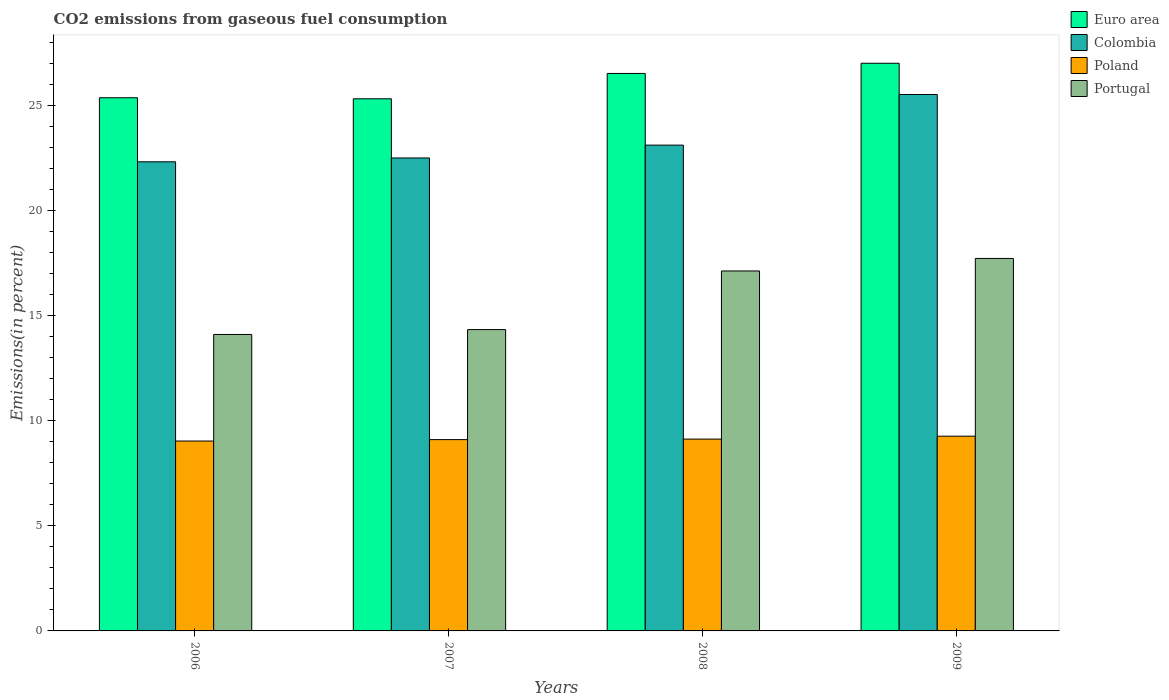How many different coloured bars are there?
Make the answer very short. 4. Are the number of bars on each tick of the X-axis equal?
Give a very brief answer. Yes. What is the label of the 3rd group of bars from the left?
Make the answer very short. 2008. In how many cases, is the number of bars for a given year not equal to the number of legend labels?
Ensure brevity in your answer.  0. What is the total CO2 emitted in Euro area in 2008?
Provide a succinct answer. 26.52. Across all years, what is the maximum total CO2 emitted in Poland?
Your response must be concise. 9.26. Across all years, what is the minimum total CO2 emitted in Poland?
Offer a terse response. 9.03. In which year was the total CO2 emitted in Euro area maximum?
Provide a short and direct response. 2009. What is the total total CO2 emitted in Portugal in the graph?
Provide a short and direct response. 63.27. What is the difference between the total CO2 emitted in Colombia in 2007 and that in 2009?
Give a very brief answer. -3.02. What is the difference between the total CO2 emitted in Portugal in 2007 and the total CO2 emitted in Poland in 2006?
Your answer should be compact. 5.3. What is the average total CO2 emitted in Euro area per year?
Your answer should be very brief. 26.05. In the year 2008, what is the difference between the total CO2 emitted in Colombia and total CO2 emitted in Portugal?
Offer a terse response. 5.99. What is the ratio of the total CO2 emitted in Colombia in 2007 to that in 2008?
Offer a terse response. 0.97. Is the difference between the total CO2 emitted in Colombia in 2007 and 2008 greater than the difference between the total CO2 emitted in Portugal in 2007 and 2008?
Offer a terse response. Yes. What is the difference between the highest and the second highest total CO2 emitted in Poland?
Give a very brief answer. 0.14. What is the difference between the highest and the lowest total CO2 emitted in Portugal?
Your response must be concise. 3.62. In how many years, is the total CO2 emitted in Portugal greater than the average total CO2 emitted in Portugal taken over all years?
Your response must be concise. 2. Is it the case that in every year, the sum of the total CO2 emitted in Portugal and total CO2 emitted in Euro area is greater than the sum of total CO2 emitted in Colombia and total CO2 emitted in Poland?
Ensure brevity in your answer.  Yes. Is it the case that in every year, the sum of the total CO2 emitted in Colombia and total CO2 emitted in Euro area is greater than the total CO2 emitted in Portugal?
Your response must be concise. Yes. How many bars are there?
Provide a succinct answer. 16. How many years are there in the graph?
Give a very brief answer. 4. What is the difference between two consecutive major ticks on the Y-axis?
Make the answer very short. 5. Are the values on the major ticks of Y-axis written in scientific E-notation?
Provide a succinct answer. No. Does the graph contain grids?
Your answer should be compact. No. How many legend labels are there?
Your answer should be very brief. 4. How are the legend labels stacked?
Offer a very short reply. Vertical. What is the title of the graph?
Your answer should be compact. CO2 emissions from gaseous fuel consumption. What is the label or title of the X-axis?
Give a very brief answer. Years. What is the label or title of the Y-axis?
Your response must be concise. Emissions(in percent). What is the Emissions(in percent) in Euro area in 2006?
Give a very brief answer. 25.36. What is the Emissions(in percent) of Colombia in 2006?
Make the answer very short. 22.31. What is the Emissions(in percent) of Poland in 2006?
Ensure brevity in your answer.  9.03. What is the Emissions(in percent) in Portugal in 2006?
Ensure brevity in your answer.  14.1. What is the Emissions(in percent) in Euro area in 2007?
Keep it short and to the point. 25.31. What is the Emissions(in percent) in Colombia in 2007?
Make the answer very short. 22.5. What is the Emissions(in percent) in Poland in 2007?
Offer a very short reply. 9.1. What is the Emissions(in percent) of Portugal in 2007?
Offer a terse response. 14.33. What is the Emissions(in percent) in Euro area in 2008?
Provide a short and direct response. 26.52. What is the Emissions(in percent) of Colombia in 2008?
Your answer should be very brief. 23.11. What is the Emissions(in percent) in Poland in 2008?
Provide a succinct answer. 9.12. What is the Emissions(in percent) of Portugal in 2008?
Offer a terse response. 17.12. What is the Emissions(in percent) of Euro area in 2009?
Provide a short and direct response. 27. What is the Emissions(in percent) in Colombia in 2009?
Provide a succinct answer. 25.52. What is the Emissions(in percent) of Poland in 2009?
Make the answer very short. 9.26. What is the Emissions(in percent) in Portugal in 2009?
Your response must be concise. 17.72. Across all years, what is the maximum Emissions(in percent) of Euro area?
Offer a very short reply. 27. Across all years, what is the maximum Emissions(in percent) of Colombia?
Offer a very short reply. 25.52. Across all years, what is the maximum Emissions(in percent) in Poland?
Your answer should be very brief. 9.26. Across all years, what is the maximum Emissions(in percent) in Portugal?
Provide a succinct answer. 17.72. Across all years, what is the minimum Emissions(in percent) of Euro area?
Keep it short and to the point. 25.31. Across all years, what is the minimum Emissions(in percent) in Colombia?
Offer a very short reply. 22.31. Across all years, what is the minimum Emissions(in percent) in Poland?
Provide a short and direct response. 9.03. Across all years, what is the minimum Emissions(in percent) in Portugal?
Keep it short and to the point. 14.1. What is the total Emissions(in percent) of Euro area in the graph?
Ensure brevity in your answer.  104.19. What is the total Emissions(in percent) of Colombia in the graph?
Give a very brief answer. 93.43. What is the total Emissions(in percent) in Poland in the graph?
Make the answer very short. 36.52. What is the total Emissions(in percent) in Portugal in the graph?
Your response must be concise. 63.27. What is the difference between the Emissions(in percent) of Euro area in 2006 and that in 2007?
Offer a terse response. 0.05. What is the difference between the Emissions(in percent) in Colombia in 2006 and that in 2007?
Give a very brief answer. -0.18. What is the difference between the Emissions(in percent) in Poland in 2006 and that in 2007?
Give a very brief answer. -0.07. What is the difference between the Emissions(in percent) in Portugal in 2006 and that in 2007?
Keep it short and to the point. -0.23. What is the difference between the Emissions(in percent) of Euro area in 2006 and that in 2008?
Keep it short and to the point. -1.16. What is the difference between the Emissions(in percent) of Colombia in 2006 and that in 2008?
Give a very brief answer. -0.79. What is the difference between the Emissions(in percent) of Poland in 2006 and that in 2008?
Make the answer very short. -0.09. What is the difference between the Emissions(in percent) in Portugal in 2006 and that in 2008?
Keep it short and to the point. -3.02. What is the difference between the Emissions(in percent) in Euro area in 2006 and that in 2009?
Offer a terse response. -1.64. What is the difference between the Emissions(in percent) in Colombia in 2006 and that in 2009?
Provide a succinct answer. -3.2. What is the difference between the Emissions(in percent) of Poland in 2006 and that in 2009?
Your response must be concise. -0.23. What is the difference between the Emissions(in percent) of Portugal in 2006 and that in 2009?
Your response must be concise. -3.62. What is the difference between the Emissions(in percent) of Euro area in 2007 and that in 2008?
Keep it short and to the point. -1.21. What is the difference between the Emissions(in percent) of Colombia in 2007 and that in 2008?
Offer a terse response. -0.61. What is the difference between the Emissions(in percent) of Poland in 2007 and that in 2008?
Offer a very short reply. -0.02. What is the difference between the Emissions(in percent) of Portugal in 2007 and that in 2008?
Make the answer very short. -2.79. What is the difference between the Emissions(in percent) of Euro area in 2007 and that in 2009?
Offer a terse response. -1.69. What is the difference between the Emissions(in percent) of Colombia in 2007 and that in 2009?
Keep it short and to the point. -3.02. What is the difference between the Emissions(in percent) in Poland in 2007 and that in 2009?
Your response must be concise. -0.16. What is the difference between the Emissions(in percent) of Portugal in 2007 and that in 2009?
Offer a terse response. -3.38. What is the difference between the Emissions(in percent) in Euro area in 2008 and that in 2009?
Offer a terse response. -0.48. What is the difference between the Emissions(in percent) in Colombia in 2008 and that in 2009?
Your answer should be compact. -2.41. What is the difference between the Emissions(in percent) in Poland in 2008 and that in 2009?
Offer a very short reply. -0.14. What is the difference between the Emissions(in percent) of Portugal in 2008 and that in 2009?
Your answer should be compact. -0.6. What is the difference between the Emissions(in percent) in Euro area in 2006 and the Emissions(in percent) in Colombia in 2007?
Your answer should be very brief. 2.86. What is the difference between the Emissions(in percent) of Euro area in 2006 and the Emissions(in percent) of Poland in 2007?
Offer a very short reply. 16.26. What is the difference between the Emissions(in percent) in Euro area in 2006 and the Emissions(in percent) in Portugal in 2007?
Your answer should be compact. 11.03. What is the difference between the Emissions(in percent) in Colombia in 2006 and the Emissions(in percent) in Poland in 2007?
Provide a succinct answer. 13.21. What is the difference between the Emissions(in percent) in Colombia in 2006 and the Emissions(in percent) in Portugal in 2007?
Provide a succinct answer. 7.98. What is the difference between the Emissions(in percent) in Poland in 2006 and the Emissions(in percent) in Portugal in 2007?
Your answer should be very brief. -5.3. What is the difference between the Emissions(in percent) in Euro area in 2006 and the Emissions(in percent) in Colombia in 2008?
Offer a very short reply. 2.25. What is the difference between the Emissions(in percent) of Euro area in 2006 and the Emissions(in percent) of Poland in 2008?
Give a very brief answer. 16.24. What is the difference between the Emissions(in percent) in Euro area in 2006 and the Emissions(in percent) in Portugal in 2008?
Offer a very short reply. 8.24. What is the difference between the Emissions(in percent) of Colombia in 2006 and the Emissions(in percent) of Poland in 2008?
Your response must be concise. 13.19. What is the difference between the Emissions(in percent) in Colombia in 2006 and the Emissions(in percent) in Portugal in 2008?
Offer a very short reply. 5.19. What is the difference between the Emissions(in percent) of Poland in 2006 and the Emissions(in percent) of Portugal in 2008?
Provide a succinct answer. -8.09. What is the difference between the Emissions(in percent) in Euro area in 2006 and the Emissions(in percent) in Colombia in 2009?
Give a very brief answer. -0.15. What is the difference between the Emissions(in percent) of Euro area in 2006 and the Emissions(in percent) of Poland in 2009?
Provide a succinct answer. 16.1. What is the difference between the Emissions(in percent) in Euro area in 2006 and the Emissions(in percent) in Portugal in 2009?
Your response must be concise. 7.64. What is the difference between the Emissions(in percent) in Colombia in 2006 and the Emissions(in percent) in Poland in 2009?
Offer a very short reply. 13.05. What is the difference between the Emissions(in percent) in Colombia in 2006 and the Emissions(in percent) in Portugal in 2009?
Provide a succinct answer. 4.6. What is the difference between the Emissions(in percent) in Poland in 2006 and the Emissions(in percent) in Portugal in 2009?
Ensure brevity in your answer.  -8.68. What is the difference between the Emissions(in percent) in Euro area in 2007 and the Emissions(in percent) in Colombia in 2008?
Give a very brief answer. 2.2. What is the difference between the Emissions(in percent) in Euro area in 2007 and the Emissions(in percent) in Poland in 2008?
Your answer should be very brief. 16.19. What is the difference between the Emissions(in percent) of Euro area in 2007 and the Emissions(in percent) of Portugal in 2008?
Ensure brevity in your answer.  8.19. What is the difference between the Emissions(in percent) of Colombia in 2007 and the Emissions(in percent) of Poland in 2008?
Make the answer very short. 13.37. What is the difference between the Emissions(in percent) in Colombia in 2007 and the Emissions(in percent) in Portugal in 2008?
Make the answer very short. 5.37. What is the difference between the Emissions(in percent) of Poland in 2007 and the Emissions(in percent) of Portugal in 2008?
Offer a terse response. -8.02. What is the difference between the Emissions(in percent) of Euro area in 2007 and the Emissions(in percent) of Colombia in 2009?
Your answer should be very brief. -0.2. What is the difference between the Emissions(in percent) of Euro area in 2007 and the Emissions(in percent) of Poland in 2009?
Make the answer very short. 16.05. What is the difference between the Emissions(in percent) of Euro area in 2007 and the Emissions(in percent) of Portugal in 2009?
Your answer should be compact. 7.59. What is the difference between the Emissions(in percent) in Colombia in 2007 and the Emissions(in percent) in Poland in 2009?
Your answer should be very brief. 13.23. What is the difference between the Emissions(in percent) of Colombia in 2007 and the Emissions(in percent) of Portugal in 2009?
Your answer should be very brief. 4.78. What is the difference between the Emissions(in percent) of Poland in 2007 and the Emissions(in percent) of Portugal in 2009?
Your answer should be very brief. -8.62. What is the difference between the Emissions(in percent) in Euro area in 2008 and the Emissions(in percent) in Colombia in 2009?
Provide a succinct answer. 1. What is the difference between the Emissions(in percent) in Euro area in 2008 and the Emissions(in percent) in Poland in 2009?
Keep it short and to the point. 17.25. What is the difference between the Emissions(in percent) in Euro area in 2008 and the Emissions(in percent) in Portugal in 2009?
Keep it short and to the point. 8.8. What is the difference between the Emissions(in percent) in Colombia in 2008 and the Emissions(in percent) in Poland in 2009?
Your response must be concise. 13.84. What is the difference between the Emissions(in percent) in Colombia in 2008 and the Emissions(in percent) in Portugal in 2009?
Ensure brevity in your answer.  5.39. What is the difference between the Emissions(in percent) in Poland in 2008 and the Emissions(in percent) in Portugal in 2009?
Your answer should be very brief. -8.59. What is the average Emissions(in percent) of Euro area per year?
Keep it short and to the point. 26.05. What is the average Emissions(in percent) of Colombia per year?
Make the answer very short. 23.36. What is the average Emissions(in percent) of Poland per year?
Provide a succinct answer. 9.13. What is the average Emissions(in percent) in Portugal per year?
Keep it short and to the point. 15.82. In the year 2006, what is the difference between the Emissions(in percent) of Euro area and Emissions(in percent) of Colombia?
Your answer should be compact. 3.05. In the year 2006, what is the difference between the Emissions(in percent) in Euro area and Emissions(in percent) in Poland?
Your answer should be compact. 16.33. In the year 2006, what is the difference between the Emissions(in percent) in Euro area and Emissions(in percent) in Portugal?
Your answer should be compact. 11.26. In the year 2006, what is the difference between the Emissions(in percent) in Colombia and Emissions(in percent) in Poland?
Provide a succinct answer. 13.28. In the year 2006, what is the difference between the Emissions(in percent) in Colombia and Emissions(in percent) in Portugal?
Provide a succinct answer. 8.21. In the year 2006, what is the difference between the Emissions(in percent) of Poland and Emissions(in percent) of Portugal?
Ensure brevity in your answer.  -5.07. In the year 2007, what is the difference between the Emissions(in percent) of Euro area and Emissions(in percent) of Colombia?
Provide a succinct answer. 2.81. In the year 2007, what is the difference between the Emissions(in percent) in Euro area and Emissions(in percent) in Poland?
Keep it short and to the point. 16.21. In the year 2007, what is the difference between the Emissions(in percent) in Euro area and Emissions(in percent) in Portugal?
Ensure brevity in your answer.  10.98. In the year 2007, what is the difference between the Emissions(in percent) of Colombia and Emissions(in percent) of Poland?
Ensure brevity in your answer.  13.4. In the year 2007, what is the difference between the Emissions(in percent) of Colombia and Emissions(in percent) of Portugal?
Make the answer very short. 8.16. In the year 2007, what is the difference between the Emissions(in percent) in Poland and Emissions(in percent) in Portugal?
Offer a very short reply. -5.23. In the year 2008, what is the difference between the Emissions(in percent) of Euro area and Emissions(in percent) of Colombia?
Offer a terse response. 3.41. In the year 2008, what is the difference between the Emissions(in percent) in Euro area and Emissions(in percent) in Poland?
Provide a short and direct response. 17.39. In the year 2008, what is the difference between the Emissions(in percent) in Euro area and Emissions(in percent) in Portugal?
Provide a short and direct response. 9.4. In the year 2008, what is the difference between the Emissions(in percent) of Colombia and Emissions(in percent) of Poland?
Provide a succinct answer. 13.98. In the year 2008, what is the difference between the Emissions(in percent) in Colombia and Emissions(in percent) in Portugal?
Your answer should be very brief. 5.99. In the year 2008, what is the difference between the Emissions(in percent) of Poland and Emissions(in percent) of Portugal?
Your answer should be very brief. -8. In the year 2009, what is the difference between the Emissions(in percent) of Euro area and Emissions(in percent) of Colombia?
Your response must be concise. 1.49. In the year 2009, what is the difference between the Emissions(in percent) in Euro area and Emissions(in percent) in Poland?
Give a very brief answer. 17.74. In the year 2009, what is the difference between the Emissions(in percent) in Euro area and Emissions(in percent) in Portugal?
Your answer should be very brief. 9.28. In the year 2009, what is the difference between the Emissions(in percent) in Colombia and Emissions(in percent) in Poland?
Make the answer very short. 16.25. In the year 2009, what is the difference between the Emissions(in percent) in Colombia and Emissions(in percent) in Portugal?
Your answer should be very brief. 7.8. In the year 2009, what is the difference between the Emissions(in percent) in Poland and Emissions(in percent) in Portugal?
Provide a short and direct response. -8.45. What is the ratio of the Emissions(in percent) in Portugal in 2006 to that in 2007?
Make the answer very short. 0.98. What is the ratio of the Emissions(in percent) of Euro area in 2006 to that in 2008?
Provide a succinct answer. 0.96. What is the ratio of the Emissions(in percent) in Colombia in 2006 to that in 2008?
Your response must be concise. 0.97. What is the ratio of the Emissions(in percent) in Poland in 2006 to that in 2008?
Offer a very short reply. 0.99. What is the ratio of the Emissions(in percent) of Portugal in 2006 to that in 2008?
Ensure brevity in your answer.  0.82. What is the ratio of the Emissions(in percent) of Euro area in 2006 to that in 2009?
Provide a short and direct response. 0.94. What is the ratio of the Emissions(in percent) in Colombia in 2006 to that in 2009?
Ensure brevity in your answer.  0.87. What is the ratio of the Emissions(in percent) in Poland in 2006 to that in 2009?
Ensure brevity in your answer.  0.98. What is the ratio of the Emissions(in percent) of Portugal in 2006 to that in 2009?
Ensure brevity in your answer.  0.8. What is the ratio of the Emissions(in percent) of Euro area in 2007 to that in 2008?
Ensure brevity in your answer.  0.95. What is the ratio of the Emissions(in percent) in Colombia in 2007 to that in 2008?
Give a very brief answer. 0.97. What is the ratio of the Emissions(in percent) of Portugal in 2007 to that in 2008?
Your answer should be very brief. 0.84. What is the ratio of the Emissions(in percent) in Euro area in 2007 to that in 2009?
Offer a very short reply. 0.94. What is the ratio of the Emissions(in percent) in Colombia in 2007 to that in 2009?
Provide a succinct answer. 0.88. What is the ratio of the Emissions(in percent) of Poland in 2007 to that in 2009?
Provide a succinct answer. 0.98. What is the ratio of the Emissions(in percent) of Portugal in 2007 to that in 2009?
Provide a short and direct response. 0.81. What is the ratio of the Emissions(in percent) in Euro area in 2008 to that in 2009?
Provide a succinct answer. 0.98. What is the ratio of the Emissions(in percent) in Colombia in 2008 to that in 2009?
Your answer should be very brief. 0.91. What is the ratio of the Emissions(in percent) in Poland in 2008 to that in 2009?
Make the answer very short. 0.98. What is the ratio of the Emissions(in percent) of Portugal in 2008 to that in 2009?
Your answer should be compact. 0.97. What is the difference between the highest and the second highest Emissions(in percent) in Euro area?
Give a very brief answer. 0.48. What is the difference between the highest and the second highest Emissions(in percent) in Colombia?
Keep it short and to the point. 2.41. What is the difference between the highest and the second highest Emissions(in percent) of Poland?
Provide a short and direct response. 0.14. What is the difference between the highest and the second highest Emissions(in percent) in Portugal?
Provide a succinct answer. 0.6. What is the difference between the highest and the lowest Emissions(in percent) of Euro area?
Offer a terse response. 1.69. What is the difference between the highest and the lowest Emissions(in percent) of Colombia?
Make the answer very short. 3.2. What is the difference between the highest and the lowest Emissions(in percent) of Poland?
Keep it short and to the point. 0.23. What is the difference between the highest and the lowest Emissions(in percent) of Portugal?
Ensure brevity in your answer.  3.62. 